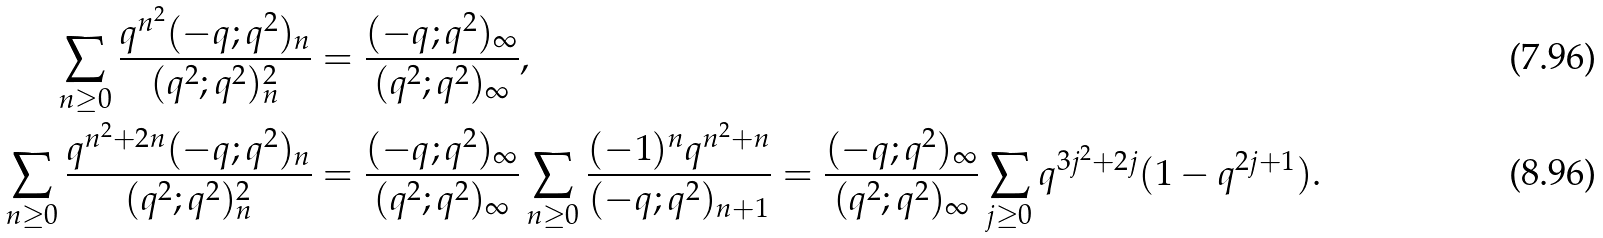<formula> <loc_0><loc_0><loc_500><loc_500>\sum _ { n \geq 0 } \frac { q ^ { n ^ { 2 } } ( - q ; q ^ { 2 } ) _ { n } } { ( q ^ { 2 } ; q ^ { 2 } ) ^ { 2 } _ { n } } & = \frac { ( - q ; q ^ { 2 } ) _ { \infty } } { ( q ^ { 2 } ; q ^ { 2 } ) _ { \infty } } , \\ \sum _ { n \geq 0 } \frac { q ^ { n ^ { 2 } + 2 n } ( - q ; q ^ { 2 } ) _ { n } } { ( q ^ { 2 } ; q ^ { 2 } ) ^ { 2 } _ { n } } & = \frac { ( - q ; q ^ { 2 } ) _ { \infty } } { ( q ^ { 2 } ; q ^ { 2 } ) _ { \infty } } \sum _ { n \geq 0 } \frac { ( - 1 ) ^ { n } q ^ { n ^ { 2 } + n } } { ( - q ; q ^ { 2 } ) _ { n + 1 } } = \frac { ( - q ; q ^ { 2 } ) _ { \infty } } { ( q ^ { 2 } ; q ^ { 2 } ) _ { \infty } } \sum _ { j \geq 0 } q ^ { 3 j ^ { 2 } + 2 j } ( 1 - q ^ { 2 j + 1 } ) .</formula> 